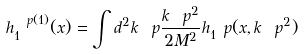<formula> <loc_0><loc_0><loc_500><loc_500>h _ { 1 } ^ { \ p ( 1 ) } ( x ) = \int d ^ { 2 } k _ { \ } p \frac { k _ { \ } p ^ { 2 } } { 2 M ^ { 2 } } h _ { 1 } ^ { \ } p ( x , k _ { \ } p ^ { 2 } )</formula> 